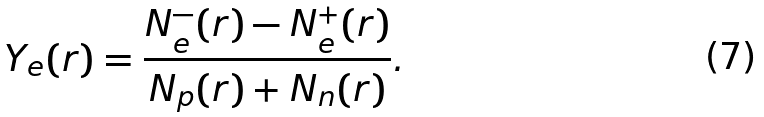<formula> <loc_0><loc_0><loc_500><loc_500>Y _ { e } ( r ) = \frac { N _ { e } ^ { - } ( r ) - N _ { e } ^ { + } ( r ) } { N _ { p } ( r ) + N _ { n } ( r ) } .</formula> 